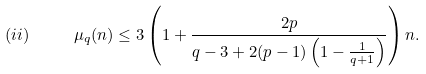<formula> <loc_0><loc_0><loc_500><loc_500>( i i ) \quad \ \mu _ { q } ( n ) \leq 3 \left ( 1 + \frac { 2 p } { q - 3 + 2 ( p - 1 ) \left ( 1 - \frac { 1 } { q + 1 } \right ) } \right ) n .</formula> 